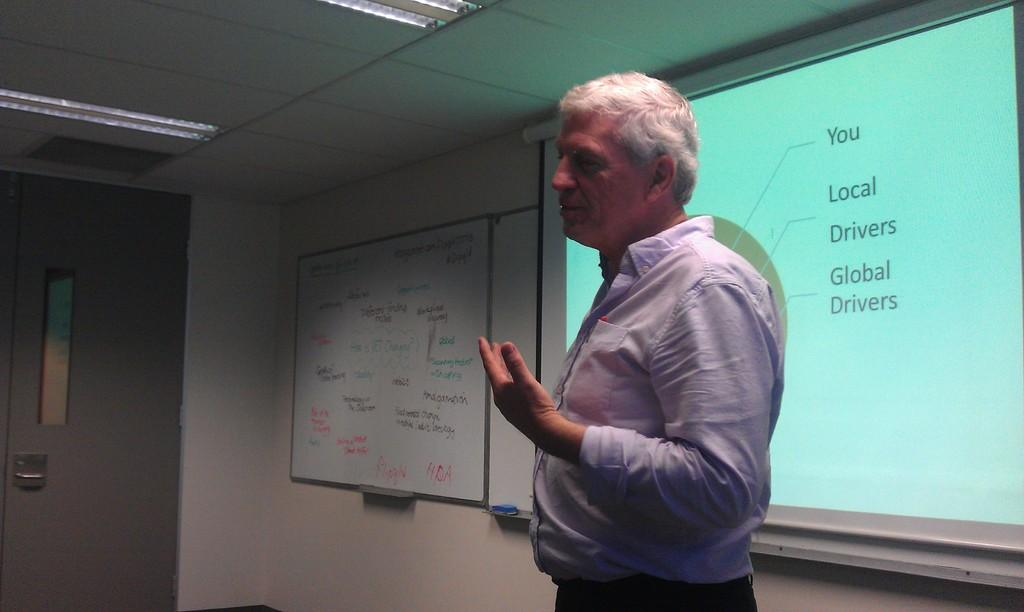Who is in the image? There is a man in the image. What is behind the man in the image? There is a projector screen behind the man. What is on the wall in the image? There is a board on the wall. What type of lighting is present in the image? Lights are present in the image. What type of juice is being served in the leather cup in the image? There is no juice or leather cup present in the image. 